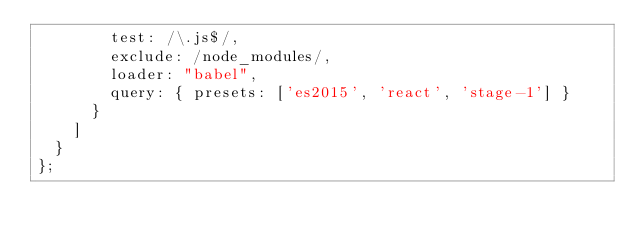<code> <loc_0><loc_0><loc_500><loc_500><_JavaScript_>        test: /\.js$/, 
        exclude: /node_modules/, 
        loader: "babel", 
        query: { presets: ['es2015', 'react', 'stage-1'] }
      }
    ]
  }
};
</code> 